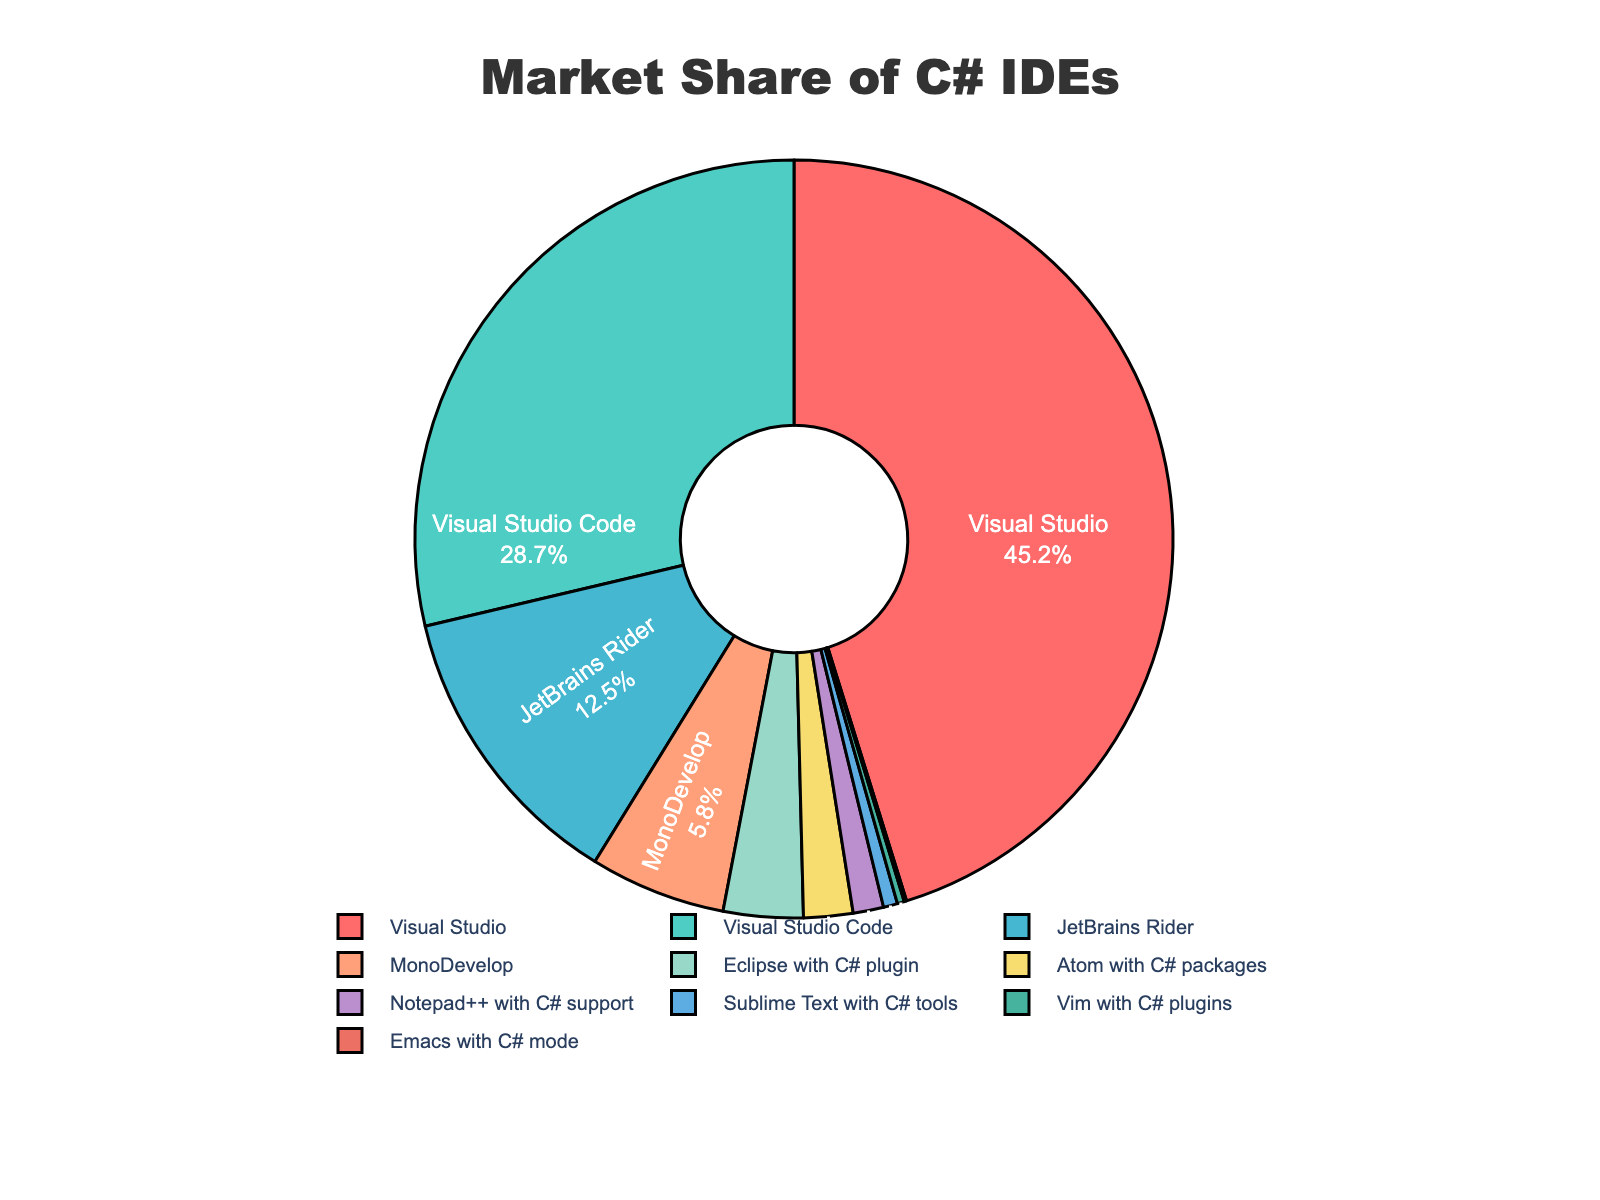Which IDE has the largest market share? The slice with the largest market share is labeled "Visual Studio" and represents 45.2%.
Answer: Visual Studio What is the total market share of Visual Studio and Visual Studio Code combined? Visual Studio has a market share of 45.2% and Visual Studio Code has 28.7%. Adding these together, 45.2 + 28.7 = 73.9%.
Answer: 73.9% Which IDE has the smallest market share? The pie chart shows that "Emacs with C# mode" has the smallest slice, representing 0.1%.
Answer: Emacs with C# mode How much larger is the market share of Visual Studio compared to JetBrains Rider? Visual Studio has 45.2% and JetBrains Rider has 12.5%. Subtracting these, 45.2 - 12.5 = 32.7%.
Answer: 32.7% What is the total market share for all the IDEs that have less than 5% share individually? Adding the shares of MonoDevelop (5.8%), Eclipse with C# plugin (3.4%), Atom with C# packages (2.1%), Notepad++ with C# support (1.3%), Sublime Text with C# tools (0.6%), Vim with C# plugins (0.3%), and Emacs with C# mode (0.1%): 5.8 + 3.4 + 2.1 + 1.3 + 0.6 + 0.3 + 0.1 = 13.6%.
Answer: 13.6% Which IDEs have market shares greater than 10%? The slices labeled "Visual Studio" (45.2%), "Visual Studio Code" (28.7%), and "JetBrains Rider" (12.5%) all have market shares greater than 10%.
Answer: Visual Studio, Visual Studio Code, JetBrains Rider What is the difference in market share between the highest and the lowest? The highest share is for Visual Studio at 45.2% and the lowest is Emacs with C# mode at 0.1%. Subtracting these, 45.2 - 0.1 = 45.1%.
Answer: 45.1% How much market share do IDEs with less than 2% share contribute combined? Adding the shares of Notepad++ with C# support (1.3%), Sublime Text with C# tools (0.6%), Vim with C# plugins (0.3%), and Emacs with C# mode (0.1%): 1.3 + 0.6 + 0.3 + 0.1 = 2.3%.
Answer: 2.3% Which IDE represented by a greenish color has the closest market share to Visual Studio Code? "JetBrains Rider" is represented by a greenish color and is the closest in share to Visual Studio Code among all the other IDEs. Rider has 12.5% as compared to Visual Studio Code's 28.7%.
Answer: JetBrains Rider Is the sum of the market shares of MonoDevelop and Eclipse with C# plugin greater than that of JetBrains Rider? MonoDevelop has 5.8% and Eclipse with C# plugin has 3.4%. Adding these, 5.8 + 3.4 = 9.2%. JetBrains Rider has 12.5%, so 9.2% is less than 12.5%.
Answer: No 